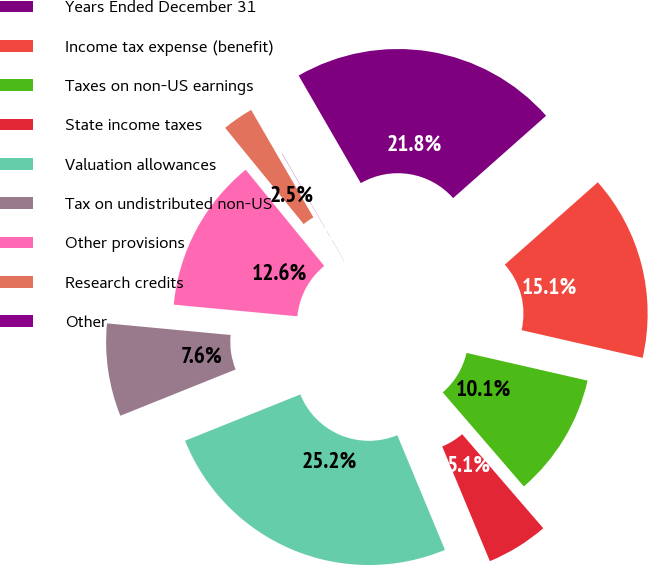Convert chart. <chart><loc_0><loc_0><loc_500><loc_500><pie_chart><fcel>Years Ended December 31<fcel>Income tax expense (benefit)<fcel>Taxes on non-US earnings<fcel>State income taxes<fcel>Valuation allowances<fcel>Tax on undistributed non-US<fcel>Other provisions<fcel>Research credits<fcel>Other<nl><fcel>21.8%<fcel>15.12%<fcel>10.09%<fcel>5.06%<fcel>25.19%<fcel>7.57%<fcel>12.61%<fcel>2.54%<fcel>0.02%<nl></chart> 